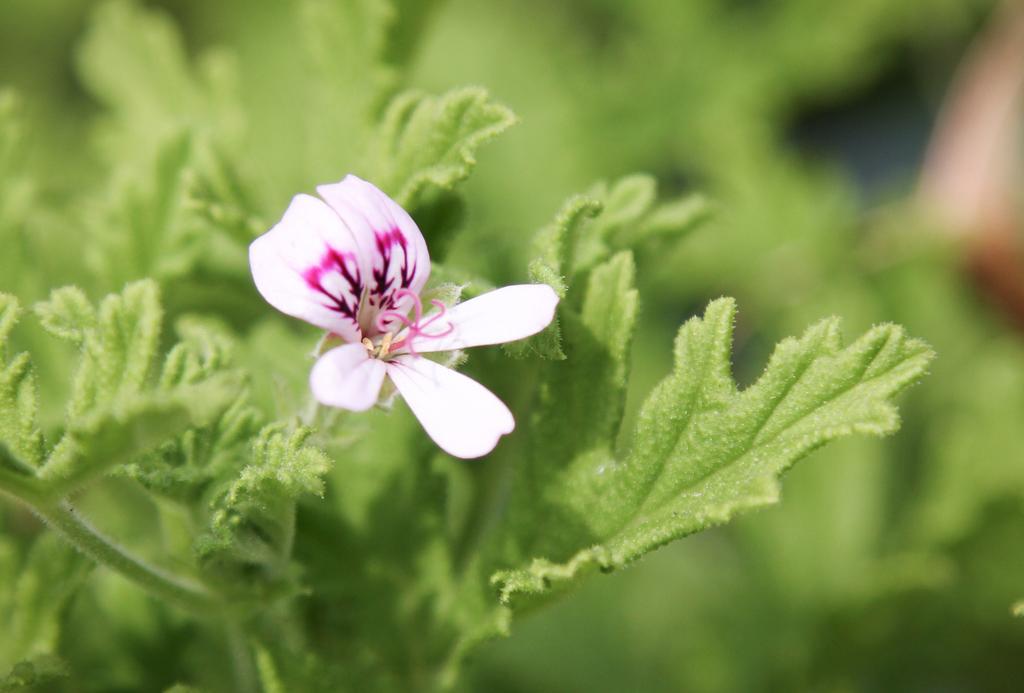How would you summarize this image in a sentence or two? In this picture we can see a flower, leaves and in the background it is blurry. 